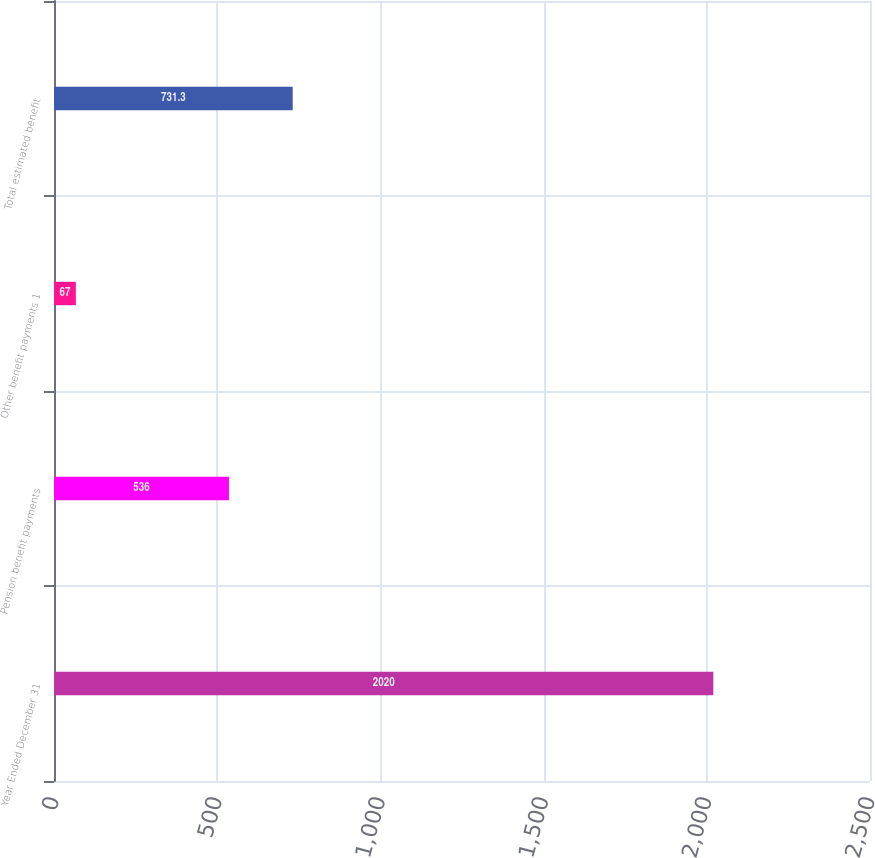Convert chart. <chart><loc_0><loc_0><loc_500><loc_500><bar_chart><fcel>Year Ended December 31<fcel>Pension benefit payments<fcel>Other benefit payments 1<fcel>Total estimated benefit<nl><fcel>2020<fcel>536<fcel>67<fcel>731.3<nl></chart> 